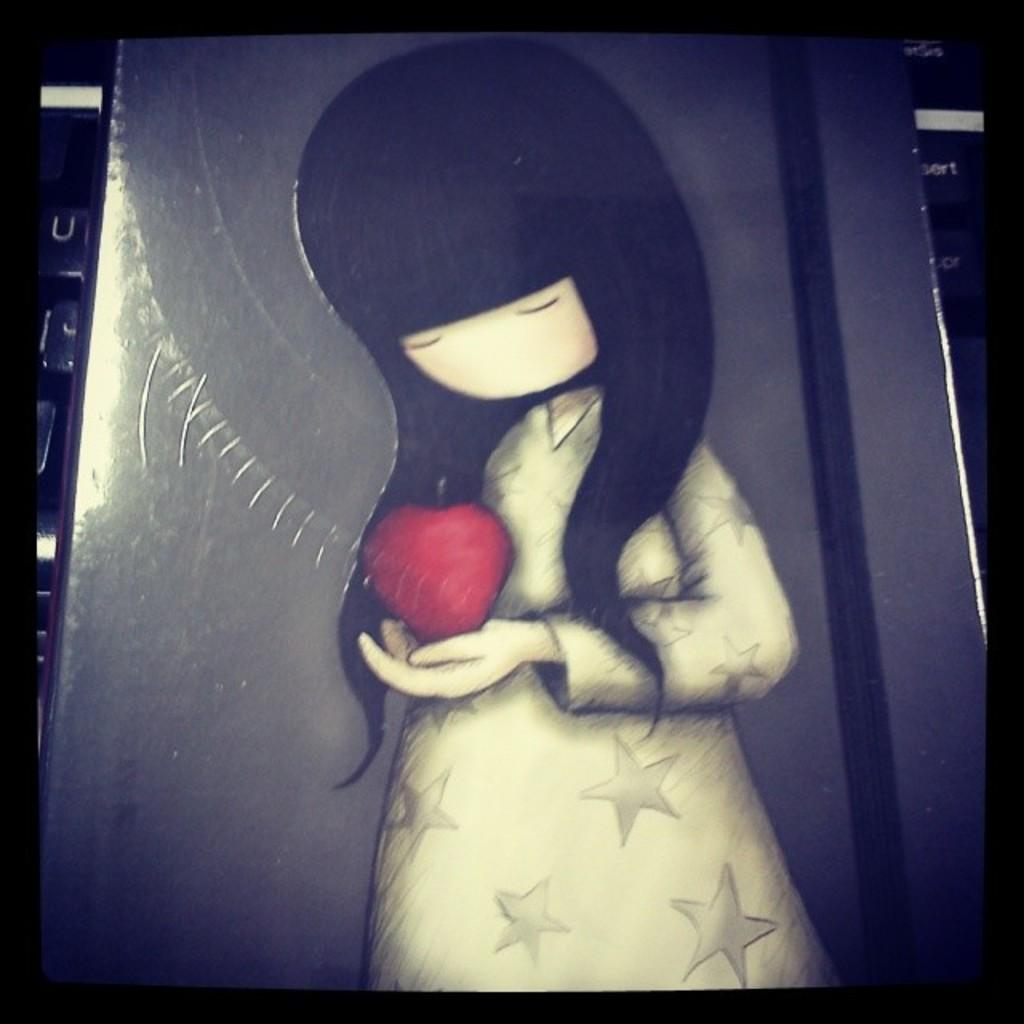What is depicted in the image? There is a cartoon of a girl in the image. What is the girl holding in the image? The girl is holding a red-colored object. What type of cherry is the girl holding in the image? There is no cherry present in the image; the girl is holding a red-colored object, but it is not specified as a cherry. 